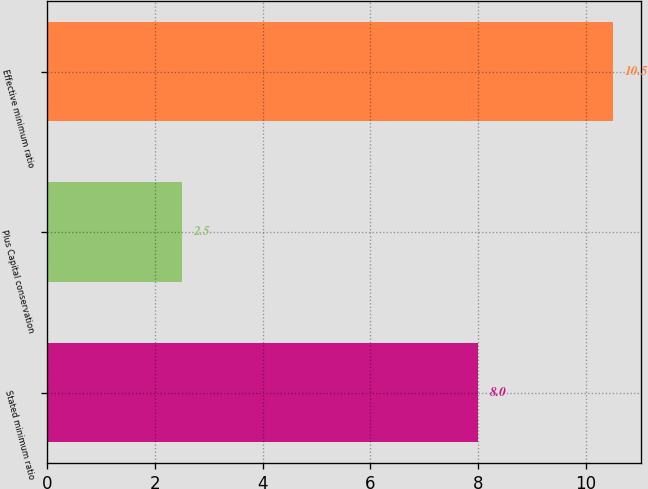Convert chart to OTSL. <chart><loc_0><loc_0><loc_500><loc_500><bar_chart><fcel>Stated minimum ratio<fcel>Plus Capital conservation<fcel>Effective minimum ratio<nl><fcel>8<fcel>2.5<fcel>10.5<nl></chart> 